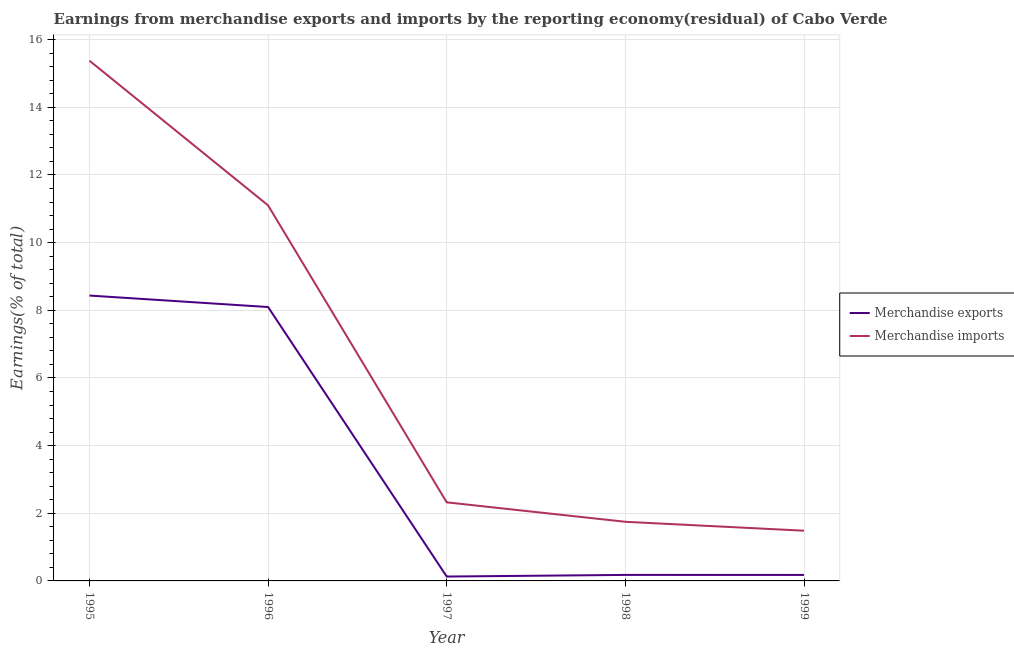How many different coloured lines are there?
Make the answer very short. 2. Does the line corresponding to earnings from merchandise imports intersect with the line corresponding to earnings from merchandise exports?
Ensure brevity in your answer.  No. What is the earnings from merchandise imports in 1999?
Provide a succinct answer. 1.48. Across all years, what is the maximum earnings from merchandise exports?
Ensure brevity in your answer.  8.44. Across all years, what is the minimum earnings from merchandise imports?
Ensure brevity in your answer.  1.48. In which year was the earnings from merchandise imports maximum?
Make the answer very short. 1995. What is the total earnings from merchandise exports in the graph?
Provide a short and direct response. 17.02. What is the difference between the earnings from merchandise exports in 1995 and that in 1996?
Provide a short and direct response. 0.34. What is the difference between the earnings from merchandise imports in 1999 and the earnings from merchandise exports in 1998?
Your answer should be compact. 1.31. What is the average earnings from merchandise imports per year?
Ensure brevity in your answer.  6.41. In the year 1997, what is the difference between the earnings from merchandise exports and earnings from merchandise imports?
Your answer should be very brief. -2.19. In how many years, is the earnings from merchandise exports greater than 9.2 %?
Keep it short and to the point. 0. What is the ratio of the earnings from merchandise imports in 1998 to that in 1999?
Your response must be concise. 1.18. What is the difference between the highest and the second highest earnings from merchandise exports?
Your response must be concise. 0.34. What is the difference between the highest and the lowest earnings from merchandise exports?
Offer a very short reply. 8.31. How many lines are there?
Provide a succinct answer. 2. Are the values on the major ticks of Y-axis written in scientific E-notation?
Provide a succinct answer. No. Where does the legend appear in the graph?
Your answer should be very brief. Center right. How are the legend labels stacked?
Your response must be concise. Vertical. What is the title of the graph?
Make the answer very short. Earnings from merchandise exports and imports by the reporting economy(residual) of Cabo Verde. What is the label or title of the X-axis?
Make the answer very short. Year. What is the label or title of the Y-axis?
Ensure brevity in your answer.  Earnings(% of total). What is the Earnings(% of total) in Merchandise exports in 1995?
Provide a short and direct response. 8.44. What is the Earnings(% of total) in Merchandise imports in 1995?
Give a very brief answer. 15.38. What is the Earnings(% of total) in Merchandise exports in 1996?
Your answer should be compact. 8.1. What is the Earnings(% of total) in Merchandise imports in 1996?
Provide a succinct answer. 11.1. What is the Earnings(% of total) of Merchandise exports in 1997?
Provide a short and direct response. 0.13. What is the Earnings(% of total) in Merchandise imports in 1997?
Make the answer very short. 2.32. What is the Earnings(% of total) in Merchandise exports in 1998?
Offer a terse response. 0.18. What is the Earnings(% of total) in Merchandise imports in 1998?
Your answer should be very brief. 1.75. What is the Earnings(% of total) of Merchandise exports in 1999?
Offer a very short reply. 0.18. What is the Earnings(% of total) in Merchandise imports in 1999?
Provide a short and direct response. 1.48. Across all years, what is the maximum Earnings(% of total) of Merchandise exports?
Offer a terse response. 8.44. Across all years, what is the maximum Earnings(% of total) in Merchandise imports?
Your answer should be compact. 15.38. Across all years, what is the minimum Earnings(% of total) of Merchandise exports?
Your answer should be compact. 0.13. Across all years, what is the minimum Earnings(% of total) in Merchandise imports?
Give a very brief answer. 1.48. What is the total Earnings(% of total) of Merchandise exports in the graph?
Your response must be concise. 17.02. What is the total Earnings(% of total) in Merchandise imports in the graph?
Ensure brevity in your answer.  32.03. What is the difference between the Earnings(% of total) of Merchandise exports in 1995 and that in 1996?
Your answer should be very brief. 0.34. What is the difference between the Earnings(% of total) in Merchandise imports in 1995 and that in 1996?
Make the answer very short. 4.28. What is the difference between the Earnings(% of total) of Merchandise exports in 1995 and that in 1997?
Make the answer very short. 8.31. What is the difference between the Earnings(% of total) of Merchandise imports in 1995 and that in 1997?
Your response must be concise. 13.06. What is the difference between the Earnings(% of total) of Merchandise exports in 1995 and that in 1998?
Your answer should be very brief. 8.26. What is the difference between the Earnings(% of total) in Merchandise imports in 1995 and that in 1998?
Offer a very short reply. 13.63. What is the difference between the Earnings(% of total) in Merchandise exports in 1995 and that in 1999?
Give a very brief answer. 8.26. What is the difference between the Earnings(% of total) of Merchandise imports in 1995 and that in 1999?
Your answer should be compact. 13.89. What is the difference between the Earnings(% of total) in Merchandise exports in 1996 and that in 1997?
Provide a short and direct response. 7.97. What is the difference between the Earnings(% of total) of Merchandise imports in 1996 and that in 1997?
Offer a very short reply. 8.78. What is the difference between the Earnings(% of total) in Merchandise exports in 1996 and that in 1998?
Your answer should be compact. 7.92. What is the difference between the Earnings(% of total) of Merchandise imports in 1996 and that in 1998?
Keep it short and to the point. 9.35. What is the difference between the Earnings(% of total) of Merchandise exports in 1996 and that in 1999?
Your answer should be compact. 7.92. What is the difference between the Earnings(% of total) in Merchandise imports in 1996 and that in 1999?
Offer a terse response. 9.62. What is the difference between the Earnings(% of total) of Merchandise exports in 1997 and that in 1998?
Your response must be concise. -0.05. What is the difference between the Earnings(% of total) of Merchandise imports in 1997 and that in 1998?
Make the answer very short. 0.57. What is the difference between the Earnings(% of total) of Merchandise exports in 1997 and that in 1999?
Offer a very short reply. -0.05. What is the difference between the Earnings(% of total) of Merchandise imports in 1997 and that in 1999?
Your response must be concise. 0.84. What is the difference between the Earnings(% of total) of Merchandise exports in 1998 and that in 1999?
Provide a succinct answer. 0. What is the difference between the Earnings(% of total) in Merchandise imports in 1998 and that in 1999?
Your answer should be very brief. 0.26. What is the difference between the Earnings(% of total) in Merchandise exports in 1995 and the Earnings(% of total) in Merchandise imports in 1996?
Keep it short and to the point. -2.67. What is the difference between the Earnings(% of total) of Merchandise exports in 1995 and the Earnings(% of total) of Merchandise imports in 1997?
Your answer should be compact. 6.11. What is the difference between the Earnings(% of total) in Merchandise exports in 1995 and the Earnings(% of total) in Merchandise imports in 1998?
Your answer should be very brief. 6.69. What is the difference between the Earnings(% of total) of Merchandise exports in 1995 and the Earnings(% of total) of Merchandise imports in 1999?
Keep it short and to the point. 6.95. What is the difference between the Earnings(% of total) of Merchandise exports in 1996 and the Earnings(% of total) of Merchandise imports in 1997?
Make the answer very short. 5.77. What is the difference between the Earnings(% of total) of Merchandise exports in 1996 and the Earnings(% of total) of Merchandise imports in 1998?
Keep it short and to the point. 6.35. What is the difference between the Earnings(% of total) of Merchandise exports in 1996 and the Earnings(% of total) of Merchandise imports in 1999?
Ensure brevity in your answer.  6.61. What is the difference between the Earnings(% of total) of Merchandise exports in 1997 and the Earnings(% of total) of Merchandise imports in 1998?
Ensure brevity in your answer.  -1.62. What is the difference between the Earnings(% of total) in Merchandise exports in 1997 and the Earnings(% of total) in Merchandise imports in 1999?
Provide a short and direct response. -1.36. What is the difference between the Earnings(% of total) in Merchandise exports in 1998 and the Earnings(% of total) in Merchandise imports in 1999?
Give a very brief answer. -1.31. What is the average Earnings(% of total) of Merchandise exports per year?
Keep it short and to the point. 3.4. What is the average Earnings(% of total) in Merchandise imports per year?
Your response must be concise. 6.41. In the year 1995, what is the difference between the Earnings(% of total) in Merchandise exports and Earnings(% of total) in Merchandise imports?
Offer a very short reply. -6.94. In the year 1996, what is the difference between the Earnings(% of total) in Merchandise exports and Earnings(% of total) in Merchandise imports?
Make the answer very short. -3. In the year 1997, what is the difference between the Earnings(% of total) of Merchandise exports and Earnings(% of total) of Merchandise imports?
Ensure brevity in your answer.  -2.19. In the year 1998, what is the difference between the Earnings(% of total) in Merchandise exports and Earnings(% of total) in Merchandise imports?
Offer a very short reply. -1.57. In the year 1999, what is the difference between the Earnings(% of total) in Merchandise exports and Earnings(% of total) in Merchandise imports?
Your answer should be compact. -1.31. What is the ratio of the Earnings(% of total) of Merchandise exports in 1995 to that in 1996?
Your answer should be very brief. 1.04. What is the ratio of the Earnings(% of total) of Merchandise imports in 1995 to that in 1996?
Give a very brief answer. 1.39. What is the ratio of the Earnings(% of total) of Merchandise exports in 1995 to that in 1997?
Keep it short and to the point. 65.24. What is the ratio of the Earnings(% of total) in Merchandise imports in 1995 to that in 1997?
Offer a terse response. 6.62. What is the ratio of the Earnings(% of total) in Merchandise exports in 1995 to that in 1998?
Make the answer very short. 47.5. What is the ratio of the Earnings(% of total) of Merchandise imports in 1995 to that in 1998?
Give a very brief answer. 8.8. What is the ratio of the Earnings(% of total) in Merchandise exports in 1995 to that in 1999?
Ensure brevity in your answer.  47.67. What is the ratio of the Earnings(% of total) in Merchandise imports in 1995 to that in 1999?
Provide a short and direct response. 10.36. What is the ratio of the Earnings(% of total) of Merchandise exports in 1996 to that in 1997?
Provide a short and direct response. 62.61. What is the ratio of the Earnings(% of total) of Merchandise imports in 1996 to that in 1997?
Your response must be concise. 4.78. What is the ratio of the Earnings(% of total) in Merchandise exports in 1996 to that in 1998?
Keep it short and to the point. 45.59. What is the ratio of the Earnings(% of total) of Merchandise imports in 1996 to that in 1998?
Your answer should be compact. 6.35. What is the ratio of the Earnings(% of total) of Merchandise exports in 1996 to that in 1999?
Offer a very short reply. 45.75. What is the ratio of the Earnings(% of total) in Merchandise imports in 1996 to that in 1999?
Your answer should be very brief. 7.48. What is the ratio of the Earnings(% of total) in Merchandise exports in 1997 to that in 1998?
Provide a short and direct response. 0.73. What is the ratio of the Earnings(% of total) in Merchandise imports in 1997 to that in 1998?
Make the answer very short. 1.33. What is the ratio of the Earnings(% of total) of Merchandise exports in 1997 to that in 1999?
Ensure brevity in your answer.  0.73. What is the ratio of the Earnings(% of total) in Merchandise imports in 1997 to that in 1999?
Keep it short and to the point. 1.56. What is the ratio of the Earnings(% of total) of Merchandise imports in 1998 to that in 1999?
Offer a very short reply. 1.18. What is the difference between the highest and the second highest Earnings(% of total) in Merchandise exports?
Provide a succinct answer. 0.34. What is the difference between the highest and the second highest Earnings(% of total) in Merchandise imports?
Ensure brevity in your answer.  4.28. What is the difference between the highest and the lowest Earnings(% of total) in Merchandise exports?
Offer a very short reply. 8.31. What is the difference between the highest and the lowest Earnings(% of total) in Merchandise imports?
Provide a succinct answer. 13.89. 